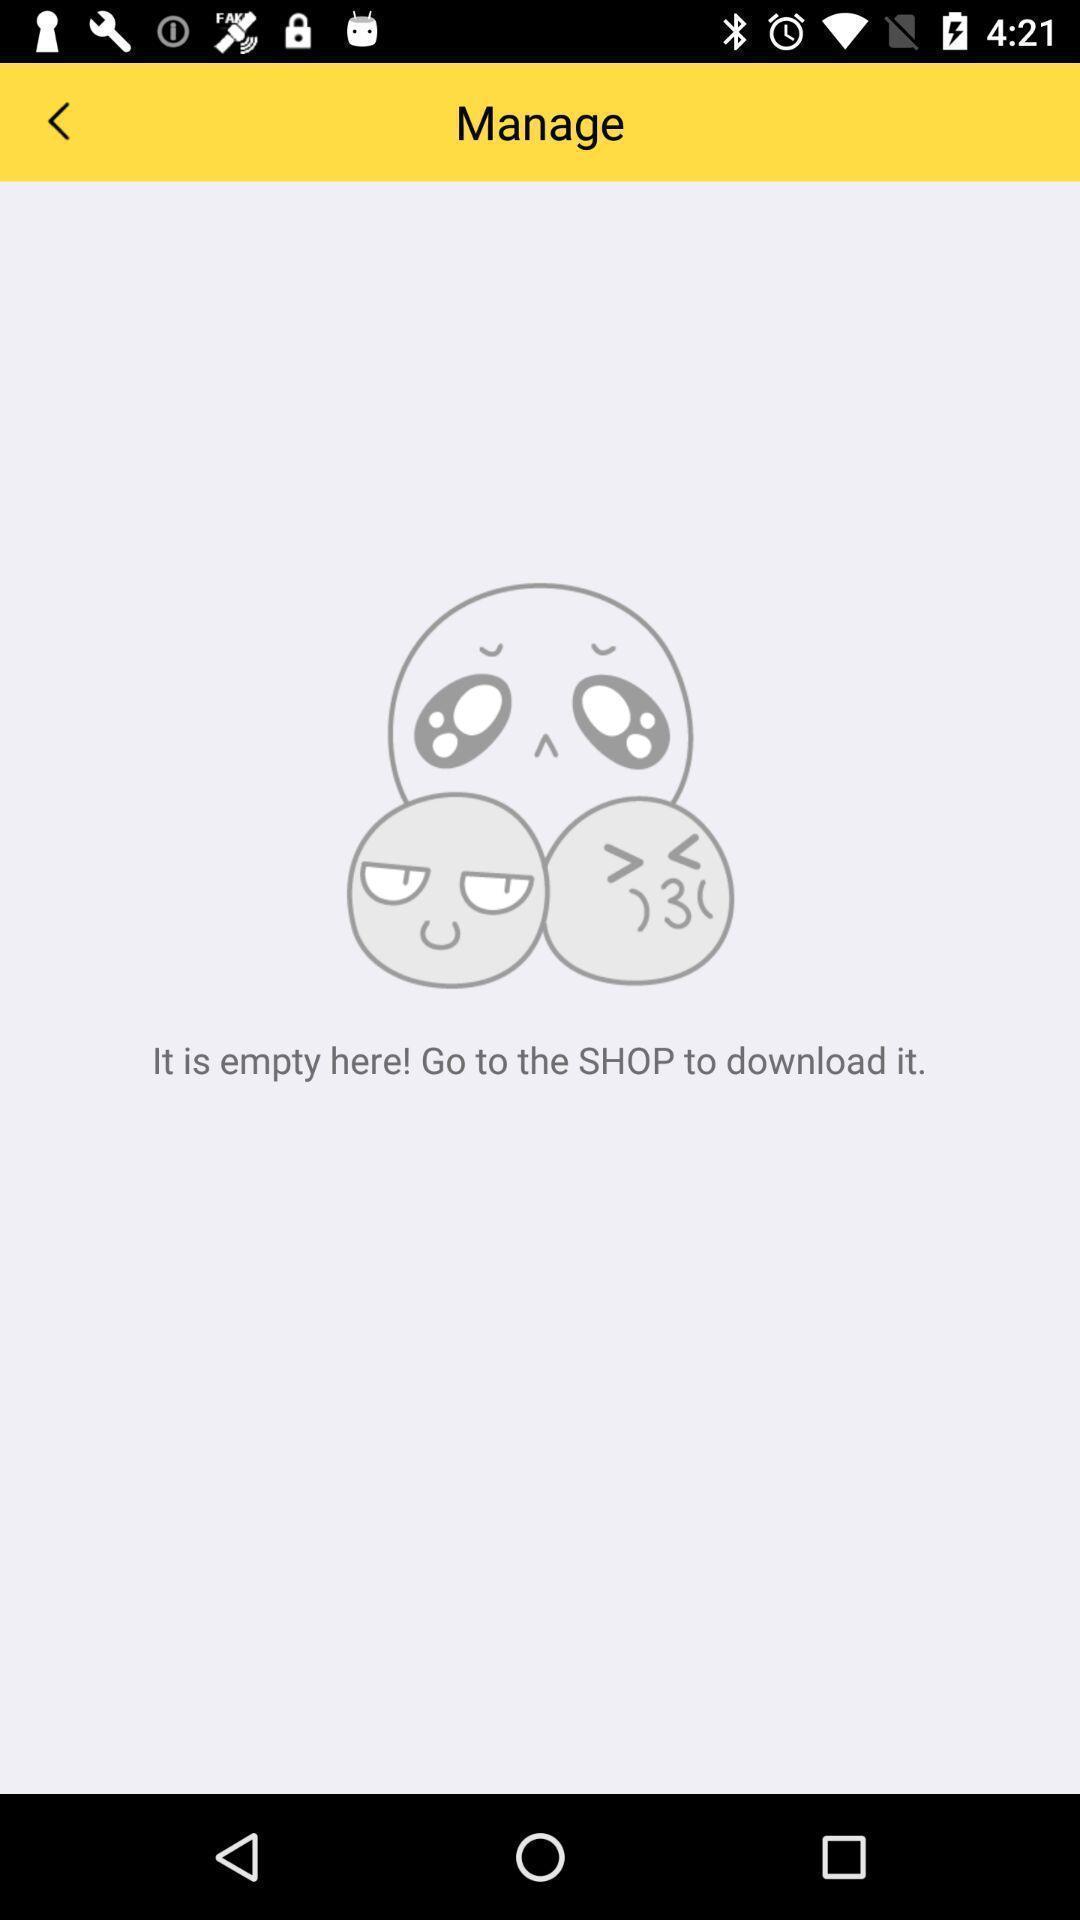Describe the key features of this screenshot. Page displaying the empty page. 